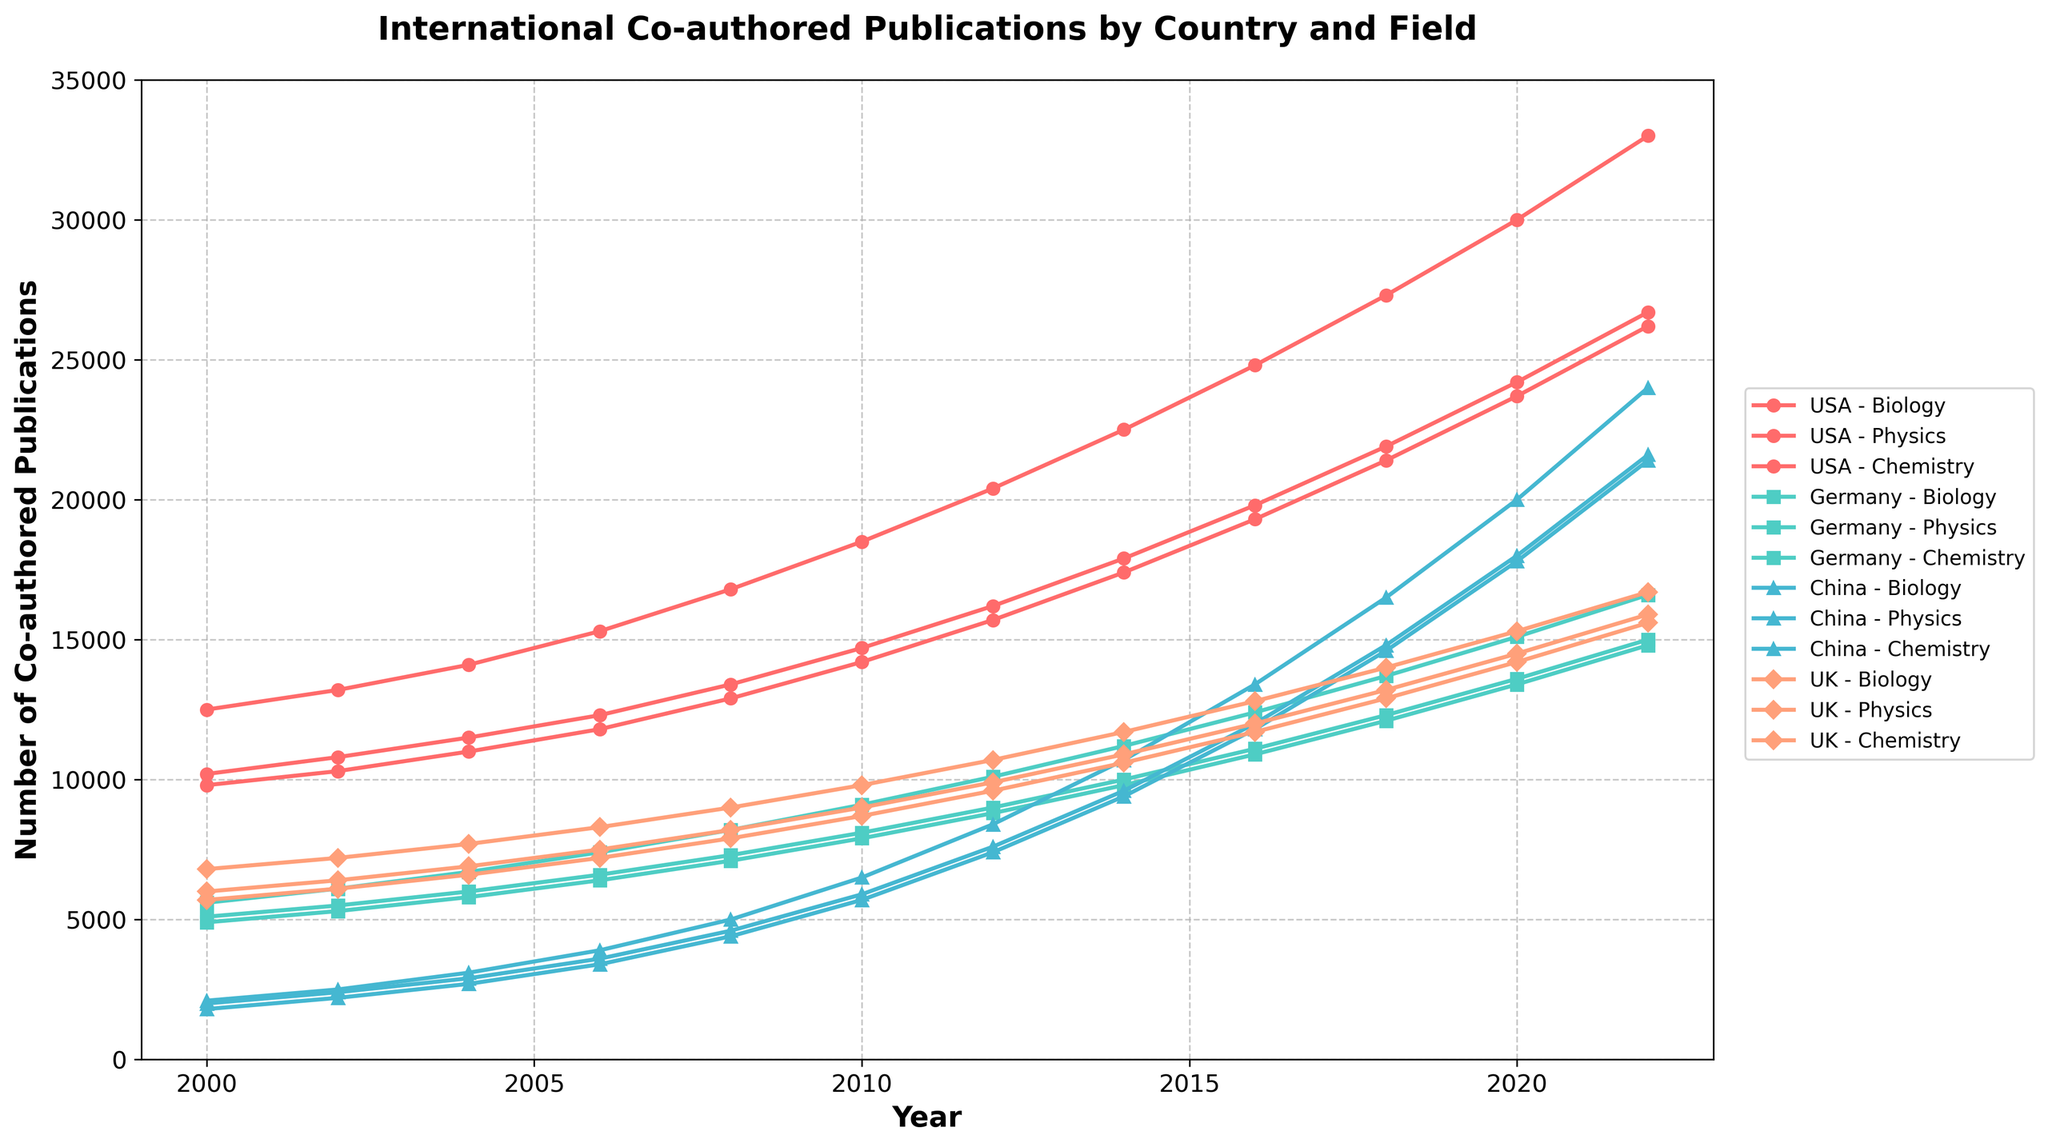Which country has the highest number of biology co-authored publications in 2022? By looking at the data points for biology in 2022, we compare the values for USA, Germany, China, and UK. USA has the highest value at 33000.
Answer: USA How much did the number of physics co-authored publications in China increase from 2000 to 2022? First, note the number of physics co-authored publications in China for 2000 and 2022. In 2000, it is 1800, and in 2022, it is 21400. The increase is 21400 - 1800 = 19600.
Answer: 19600 Which field has shown the greatest growth in the USA from 2000 to 2022? By comparing the number of publications in biology, physics, and chemistry between 2000 and 2022 for the USA, biology grows from 12500 to 33000 (+20500), physics from 9800 to 26200 (+16400), and chemistry from 10200 to 26700 (+16500). Biology shows the greatest growth.
Answer: Biology Which country had the most consistent growth across all three fields from 2000 to 2022? We examine the data for the change in the number of publications across all three fields for each country. Consistent growth means similar increments in each field. The numbers indicate that Germany had relatively steady increases across biology (5600 to 16600), physics (4900 to 14800), and chemistry (5100 to 15000).
Answer: Germany In 2016, which country and field combination had the smallest number of international co-authored publications? By checking the 2016 data, the smallest number of publications is for China's physics with 11800.
Answer: China Physics Calculate the average number of chemistry publications in the UK from 2000 to 2022. Sum the number of chemistry publications in UK over the given years: 6000 + 6400 + 6900 + 7500 + 8200 + 9000 + 9900 + 10900 + 12000 + 13200 + 14500 + 15900 = 120900. Divide by the number of years (12): 120900 / 12 = 10075.
Answer: 10075 Between China and Germany, which country saw a larger absolute increase in biology publications between 2000 and 2022? China's biology publications increased from 2100 in 2000 to 24000 in 2022, an increase of 21900. Germany's biology publications increased from 5600 to 16600, an increase of 11000. China's increase is larger.
Answer: China What is the total number of co-authored publications in all fields for the UK in 2014? Sum the number of publications in all fields for the UK in 2014: 11700 (biology) + 10600 (physics) + 10900 (chemistry) = 33200.
Answer: 33200 Compare the number of physics publications between the USA and the UK in 2020. Which country had more? In 2020, the USA had 23700 physics publications while the UK had 14200. The USA had more.
Answer: USA Describe the trend for international co-authored publications in chemistry for China from 2000 to 2022. From the data, China's chemistry publications increased steadily over the years: 2000 (2000), 2002 (2400), 2004 (2900), 2006 (3600), 2008 (4600), 2010 (5900), 2012 (7600), 2014 (9600), 2016 (12000), 2018 (14800), 2020 (18000), and 2022 (21600). Overall, it shows a consistent upward trend.
Answer: Upward trend 